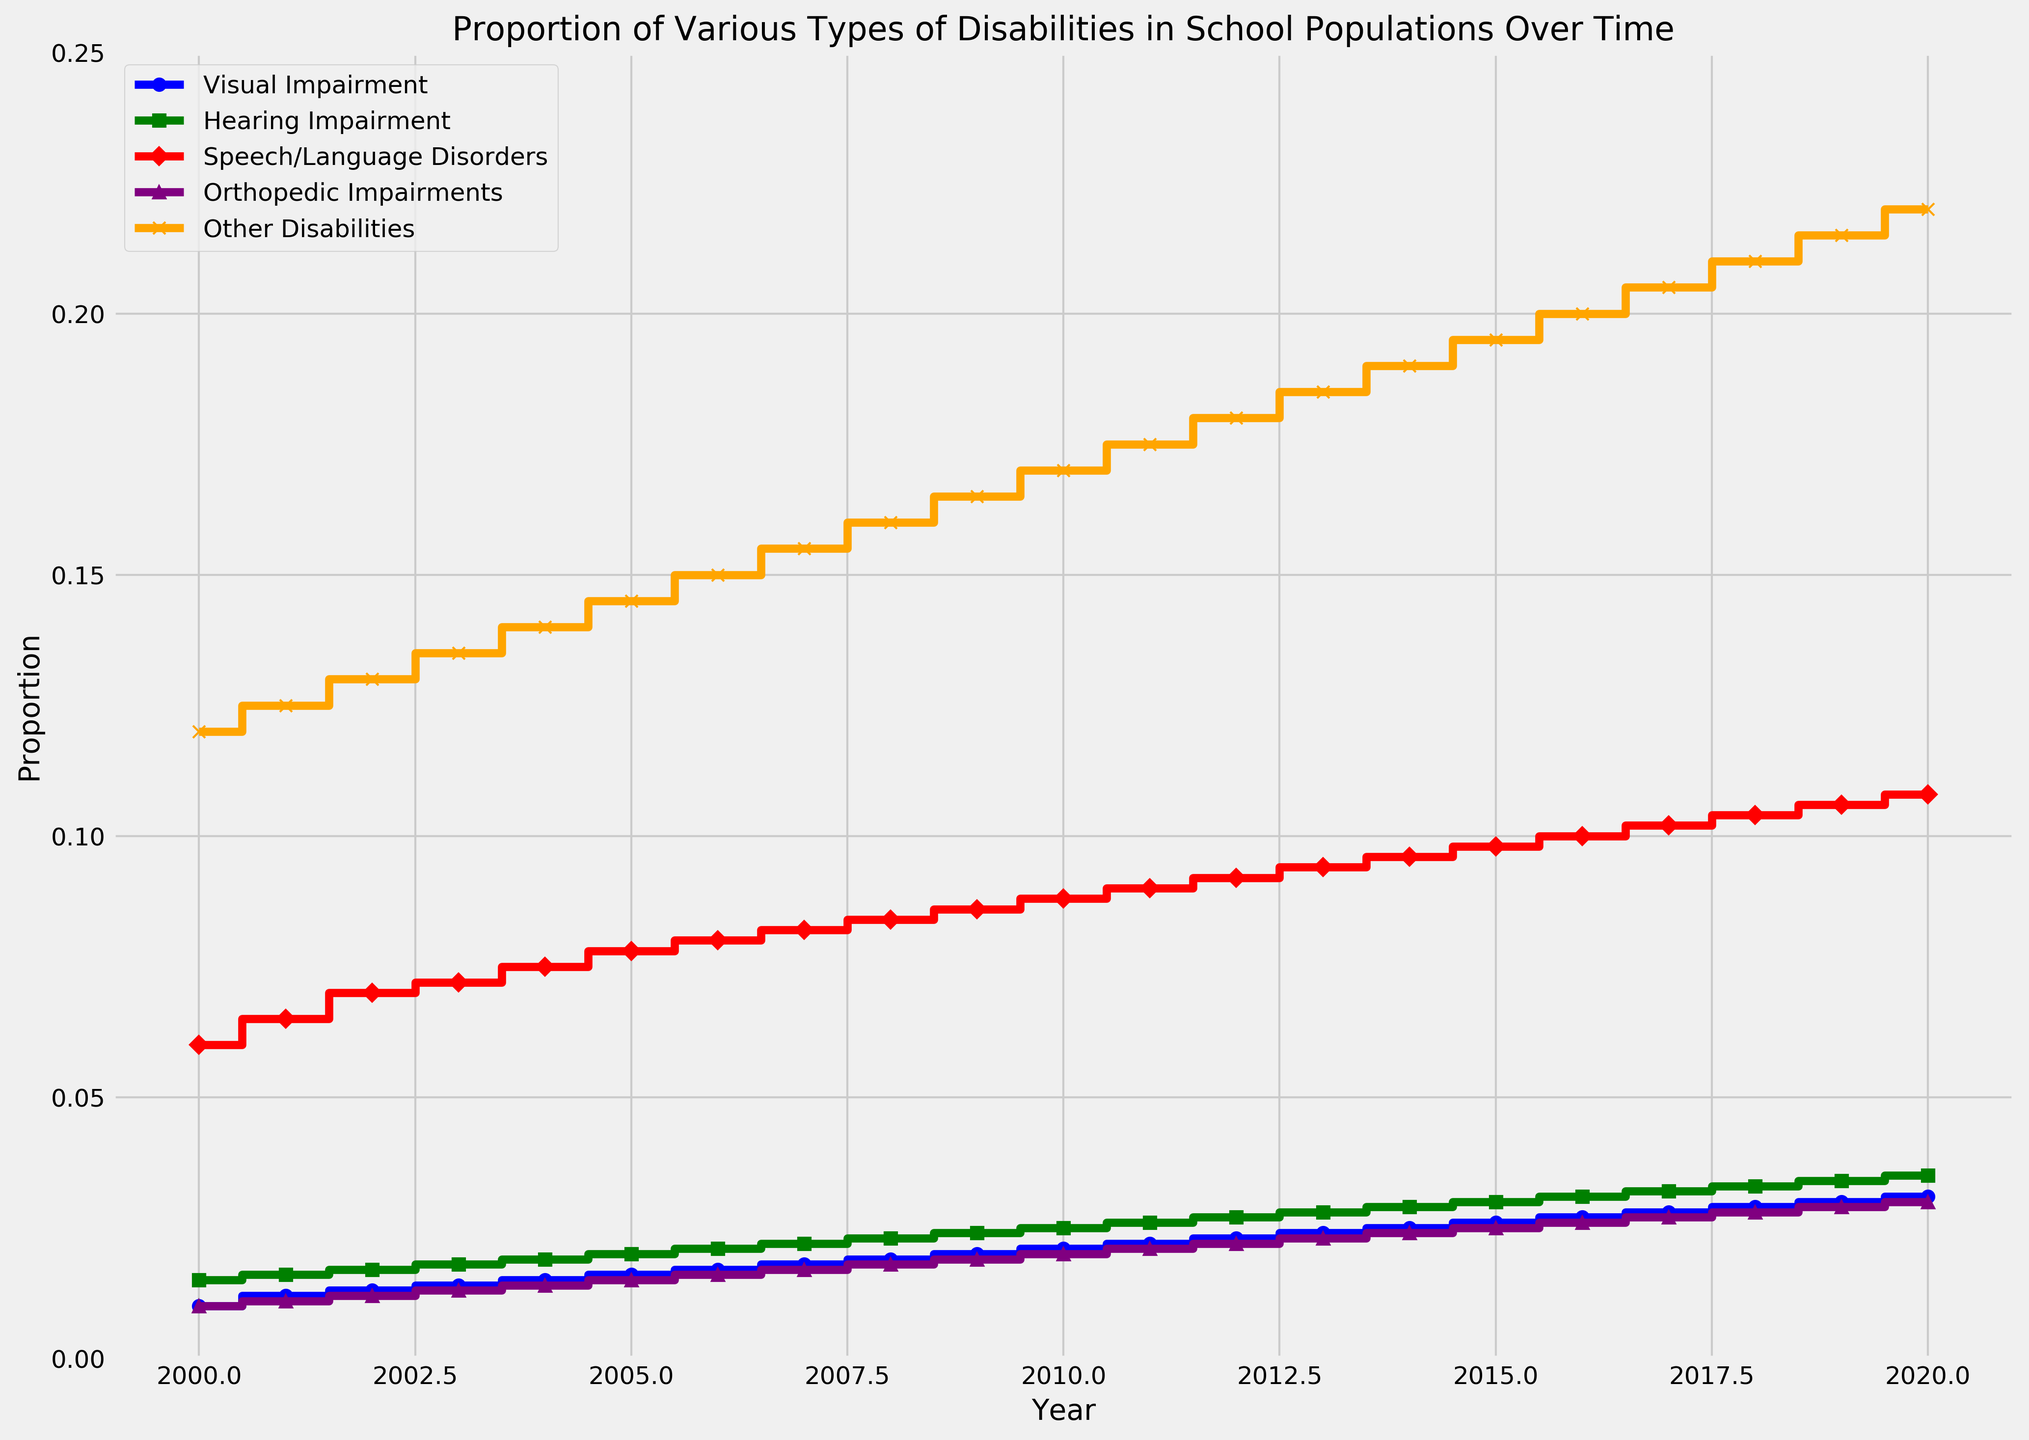What is the proportion of Visual Impairment in the year 2010? Look for the year 2010 on the x-axis and refer to the blue line (Visual Impairment). Identify the corresponding y-axis value, which represents the proportion.
Answer: 0.021 What was the greatest proportion of Speech/Language Disorders recorded between 2000 and 2020? Look for the highest point on the red line (Speech/Language Disorders) over the years. Check the y-axis value at this point.
Answer: 0.108 Between Visual Impairment and Hearing Impairment in 2015, which had a higher proportion and by how much? Compare the values for Visual Impairment (blue line) and Hearing Impairment (green line) in 2015. Subtract the smaller value from the larger value. Visual Impairment: 0.026, Hearing Impairment: 0.03. 0.03 - 0.026 = 0.004
Answer: Hearing Impairment, 0.004 In what year did the proportion of Orthopedic Impairments reach 0.02? Identify the purple line (Orthopedic Impairments) and look for its intersection with the 0.02 mark on the y-axis. Trace it back to the corresponding x-axis year.
Answer: 2010 What's the difference in the proportion of Other Disabilities from 2000 to 2020? Find the proportion of Other Disabilities (orange line) in 2000 and 2020. Subtract the 2000 value from the 2020 value. 2020: 0.22, 2000: 0.12. 0.22 - 0.12 = 0.10
Answer: 0.10 How has the proportion of Visual Impairment changed from 2000 to 2020? Identify the y-axis values of the blue line (Visual Impairment) at 2000 and 2020. Subtract the 2000 value from the 2020 value to see the change. Visual Impairment in 2000: 0.01, Visual Impairment in 2020: 0.031. 0.031 - 0.01 = 0.021
Answer: Increased by 0.021 Which type of disability showed the most gradual increase over the years? Observe the slopes of the lines representing different disabilities. The line with the most gradual (least steep) increase is the one showing the most gradual increase. Visual Impairment (blue line) has the least steep slope.
Answer: Visual Impairment What year did the proportion of Hearing Impairment surpass 0.03? Observe the green line (Hearing Impairment) and find the point where it first crosses the 0.03 mark on the y-axis. Trace it back to the corresponding x-axis year.
Answer: 2016 By how much did the proportion of Speech/Language Disorders increase from 2003 to 2008? Identify the values of the red line (Speech/Language Disorders) at 2003 and 2008. Subtract the 2003 value from the 2008 value. 2008: 0.084, 2003: 0.072. 0.084 - 0.072 = 0.012
Answer: 0.012 In which year did the proportion of all disability types first exceed 0.05? Check each line for the years they cross the 0.05 mark on the y-axis. Only Speech/Language Disorders (red line) crosses this mark. Identify the earliest year this happens.
Answer: 2000 